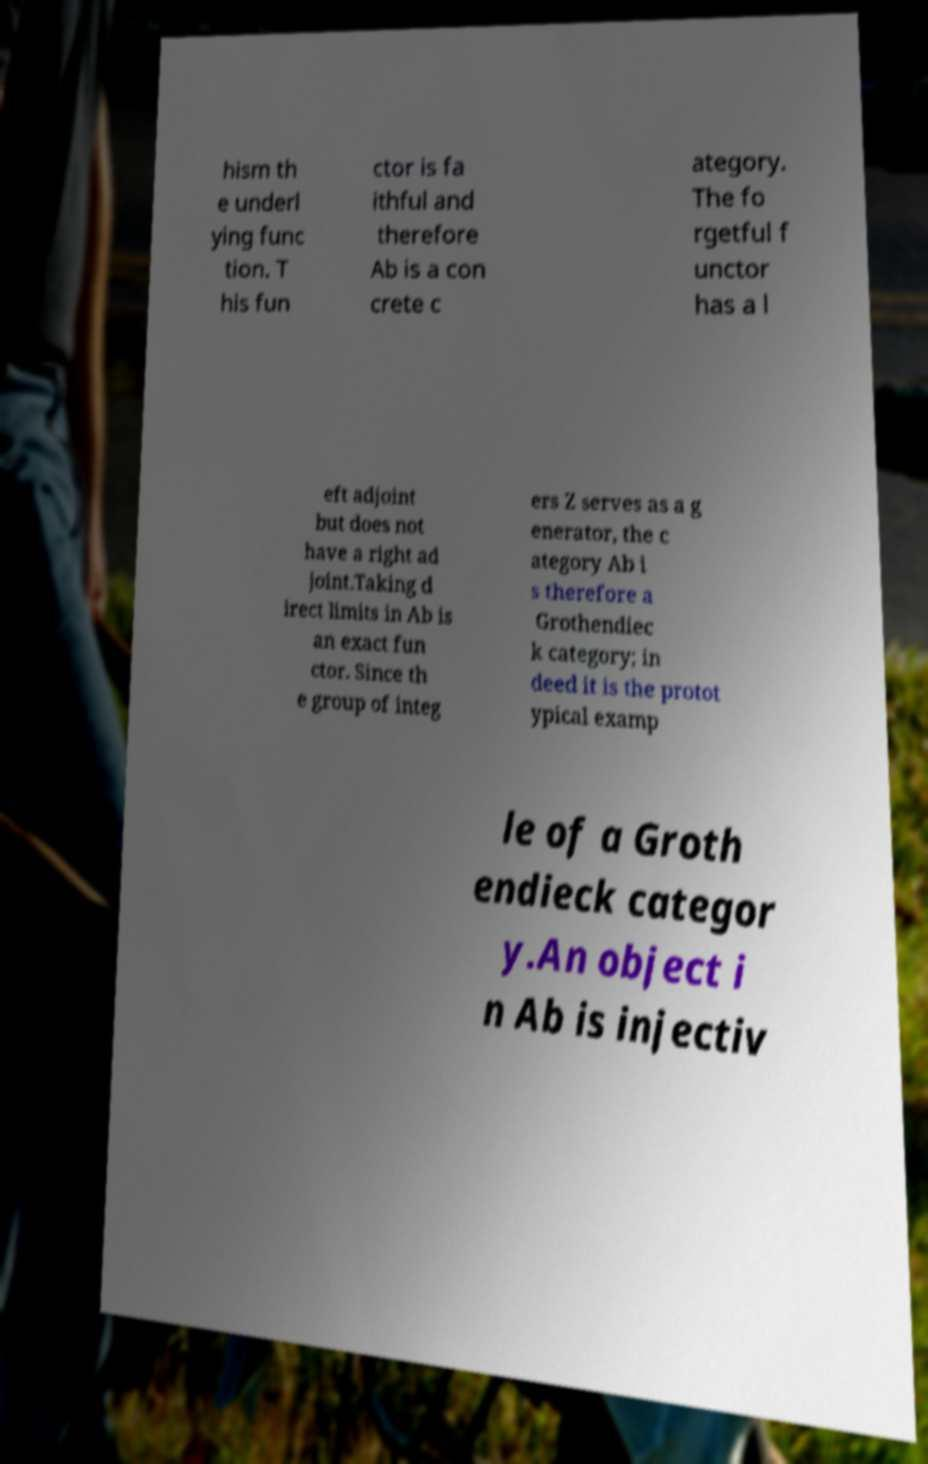There's text embedded in this image that I need extracted. Can you transcribe it verbatim? hism th e underl ying func tion. T his fun ctor is fa ithful and therefore Ab is a con crete c ategory. The fo rgetful f unctor has a l eft adjoint but does not have a right ad joint.Taking d irect limits in Ab is an exact fun ctor. Since th e group of integ ers Z serves as a g enerator, the c ategory Ab i s therefore a Grothendiec k category; in deed it is the protot ypical examp le of a Groth endieck categor y.An object i n Ab is injectiv 